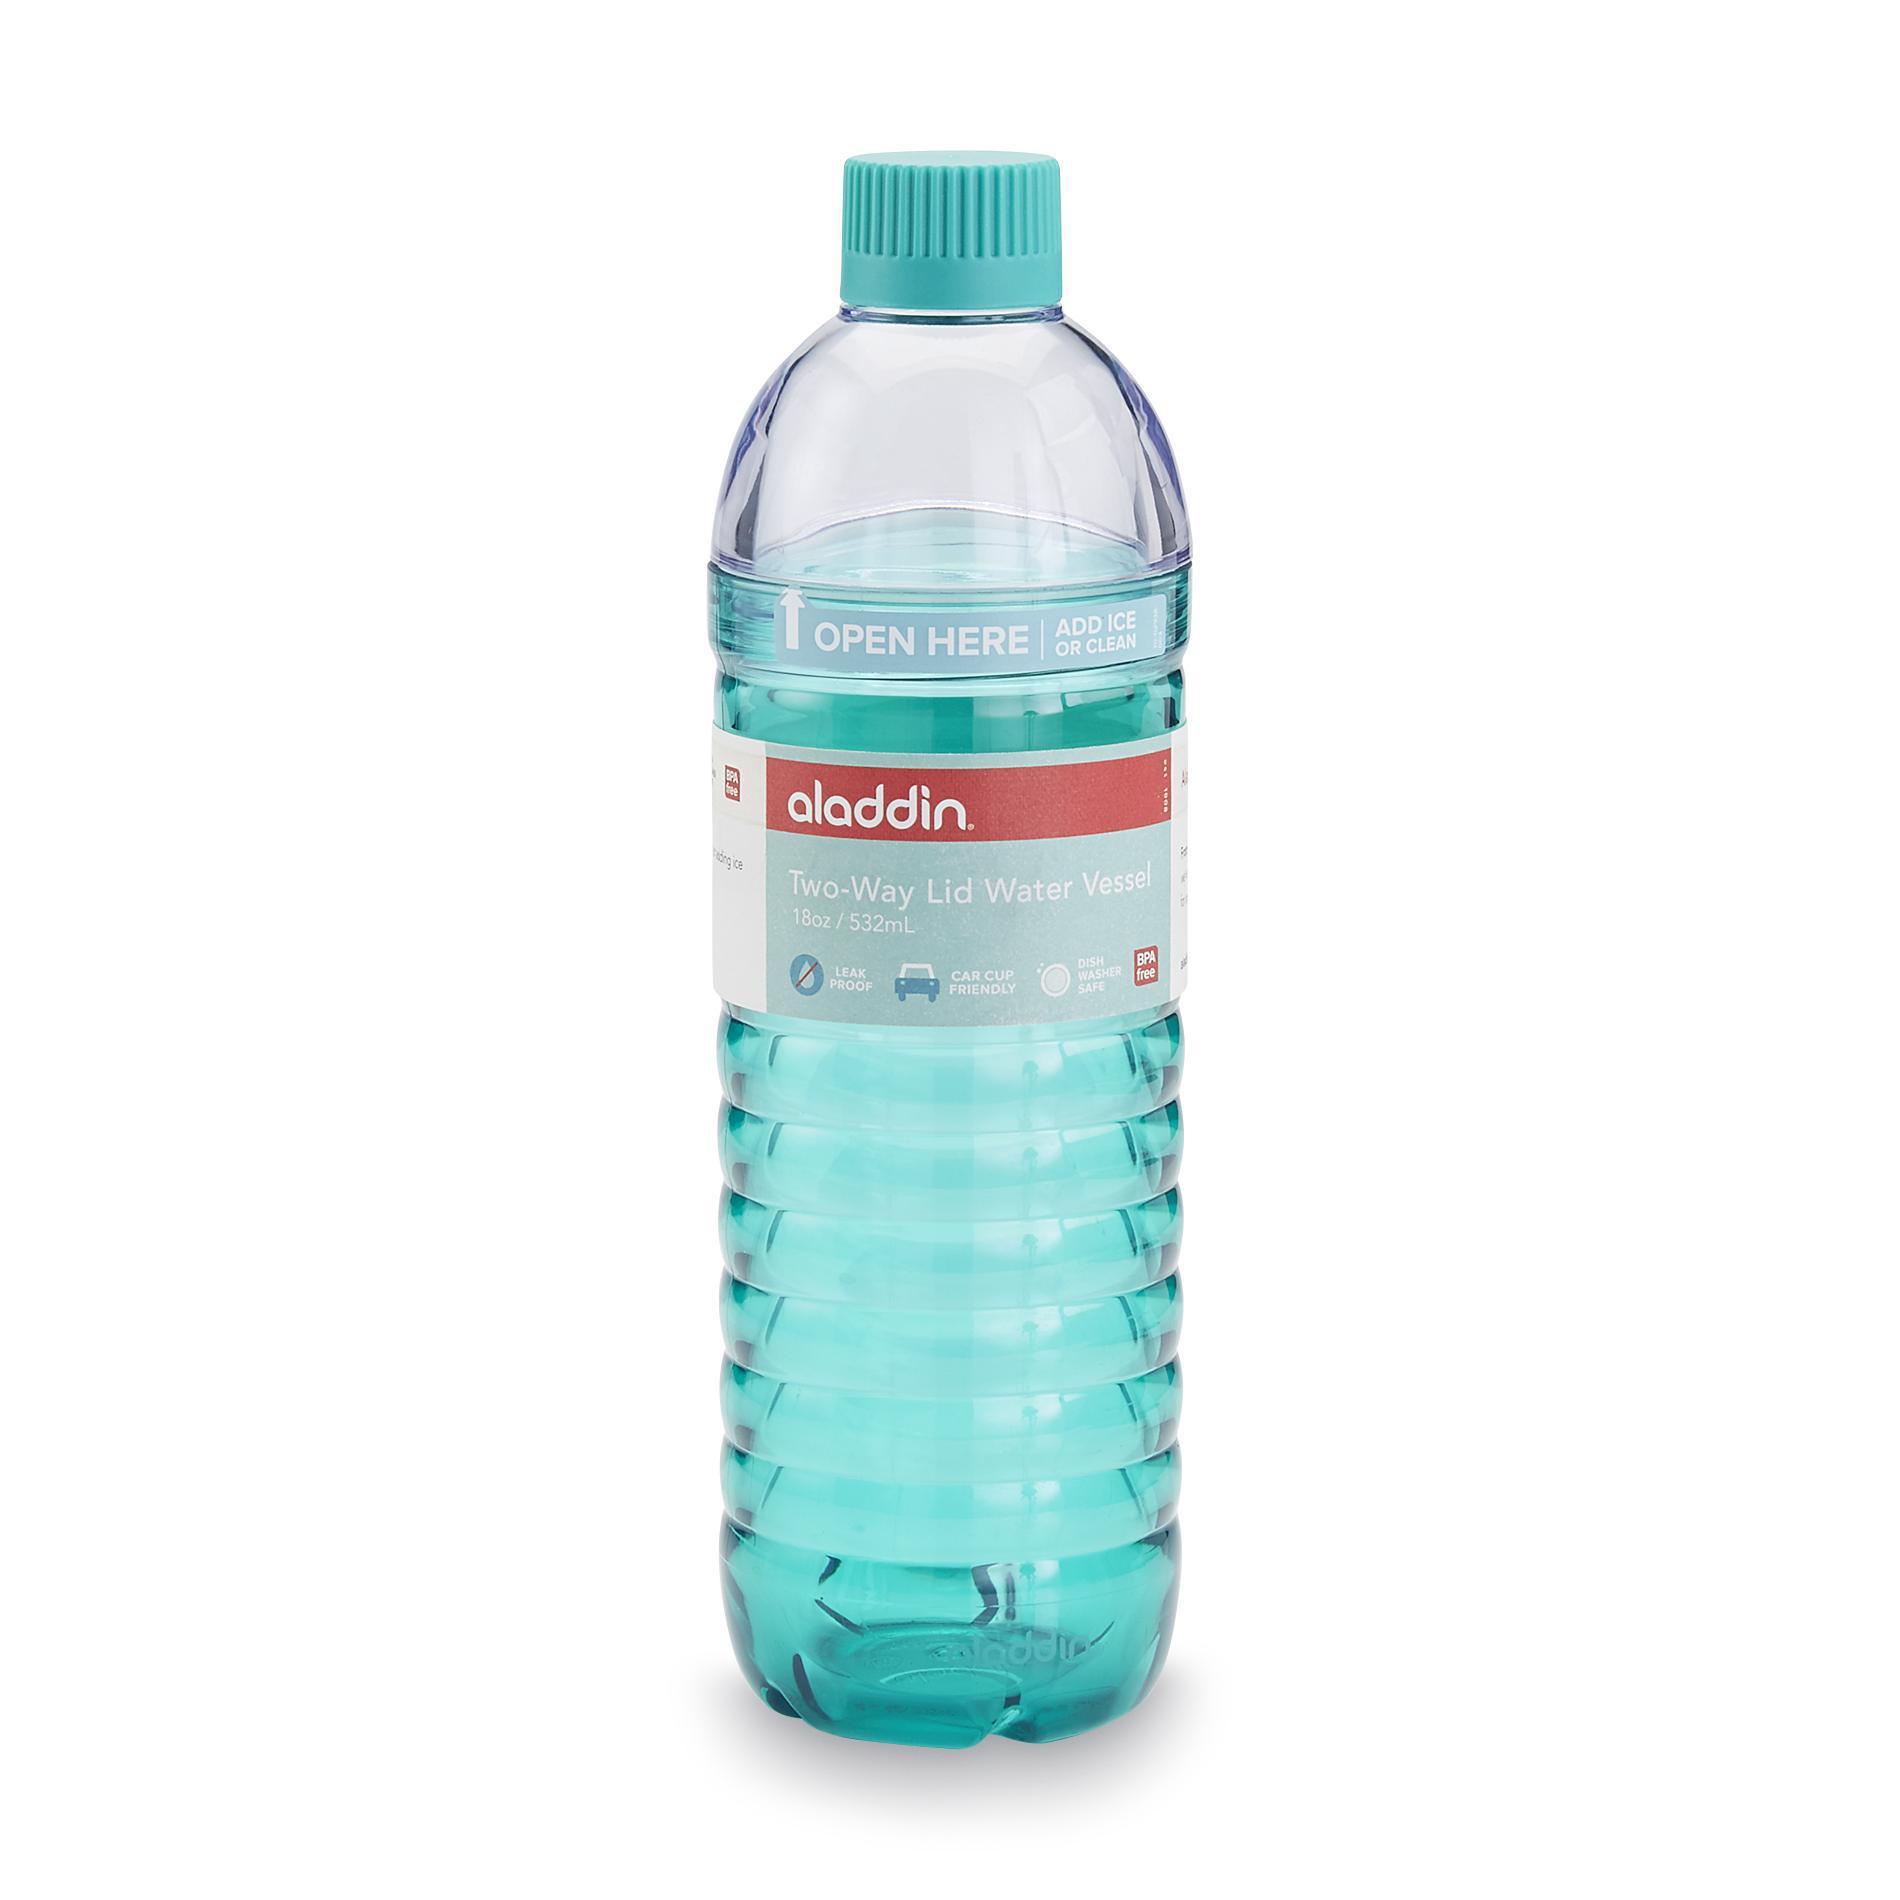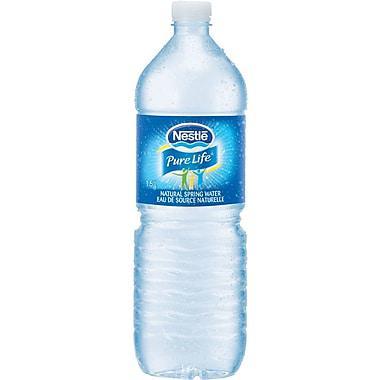The first image is the image on the left, the second image is the image on the right. Analyze the images presented: Is the assertion "An image shows some type of freezing sticks next to a water bottle." valid? Answer yes or no. No. The first image is the image on the left, the second image is the image on the right. For the images displayed, is the sentence "One of the bottles is near an ice tray." factually correct? Answer yes or no. No. 